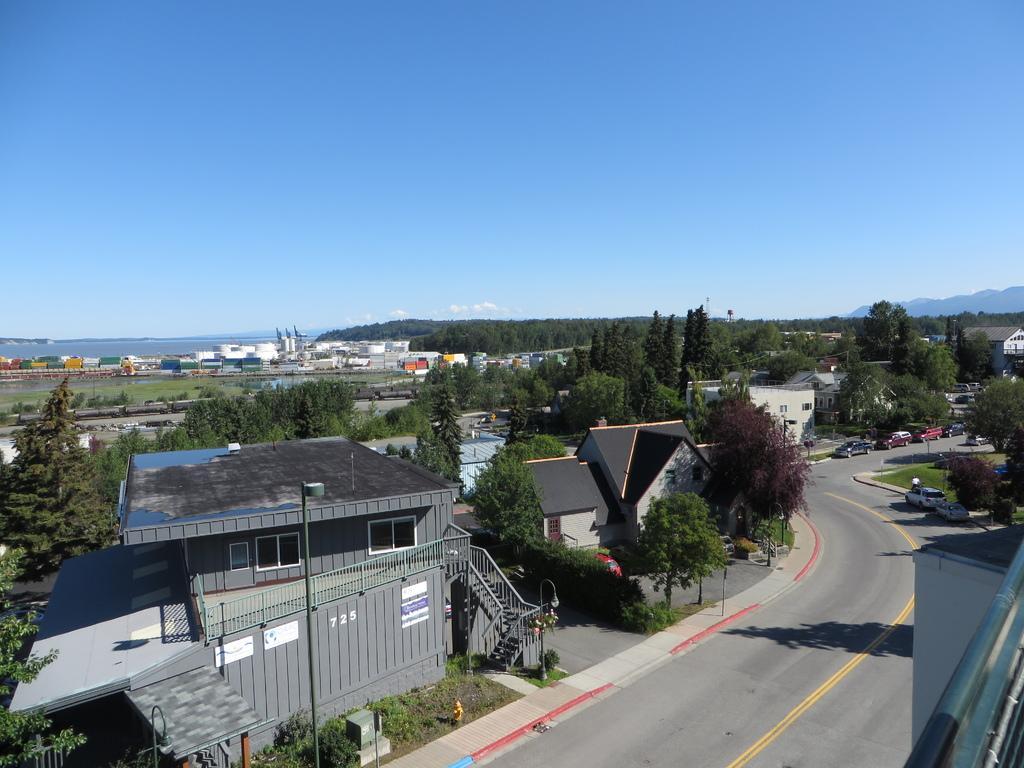In one or two sentences, can you explain what this image depicts? In this image I can see the vehicles on the road. In the background, I can see the buildings, trees and clouds in the sky. 